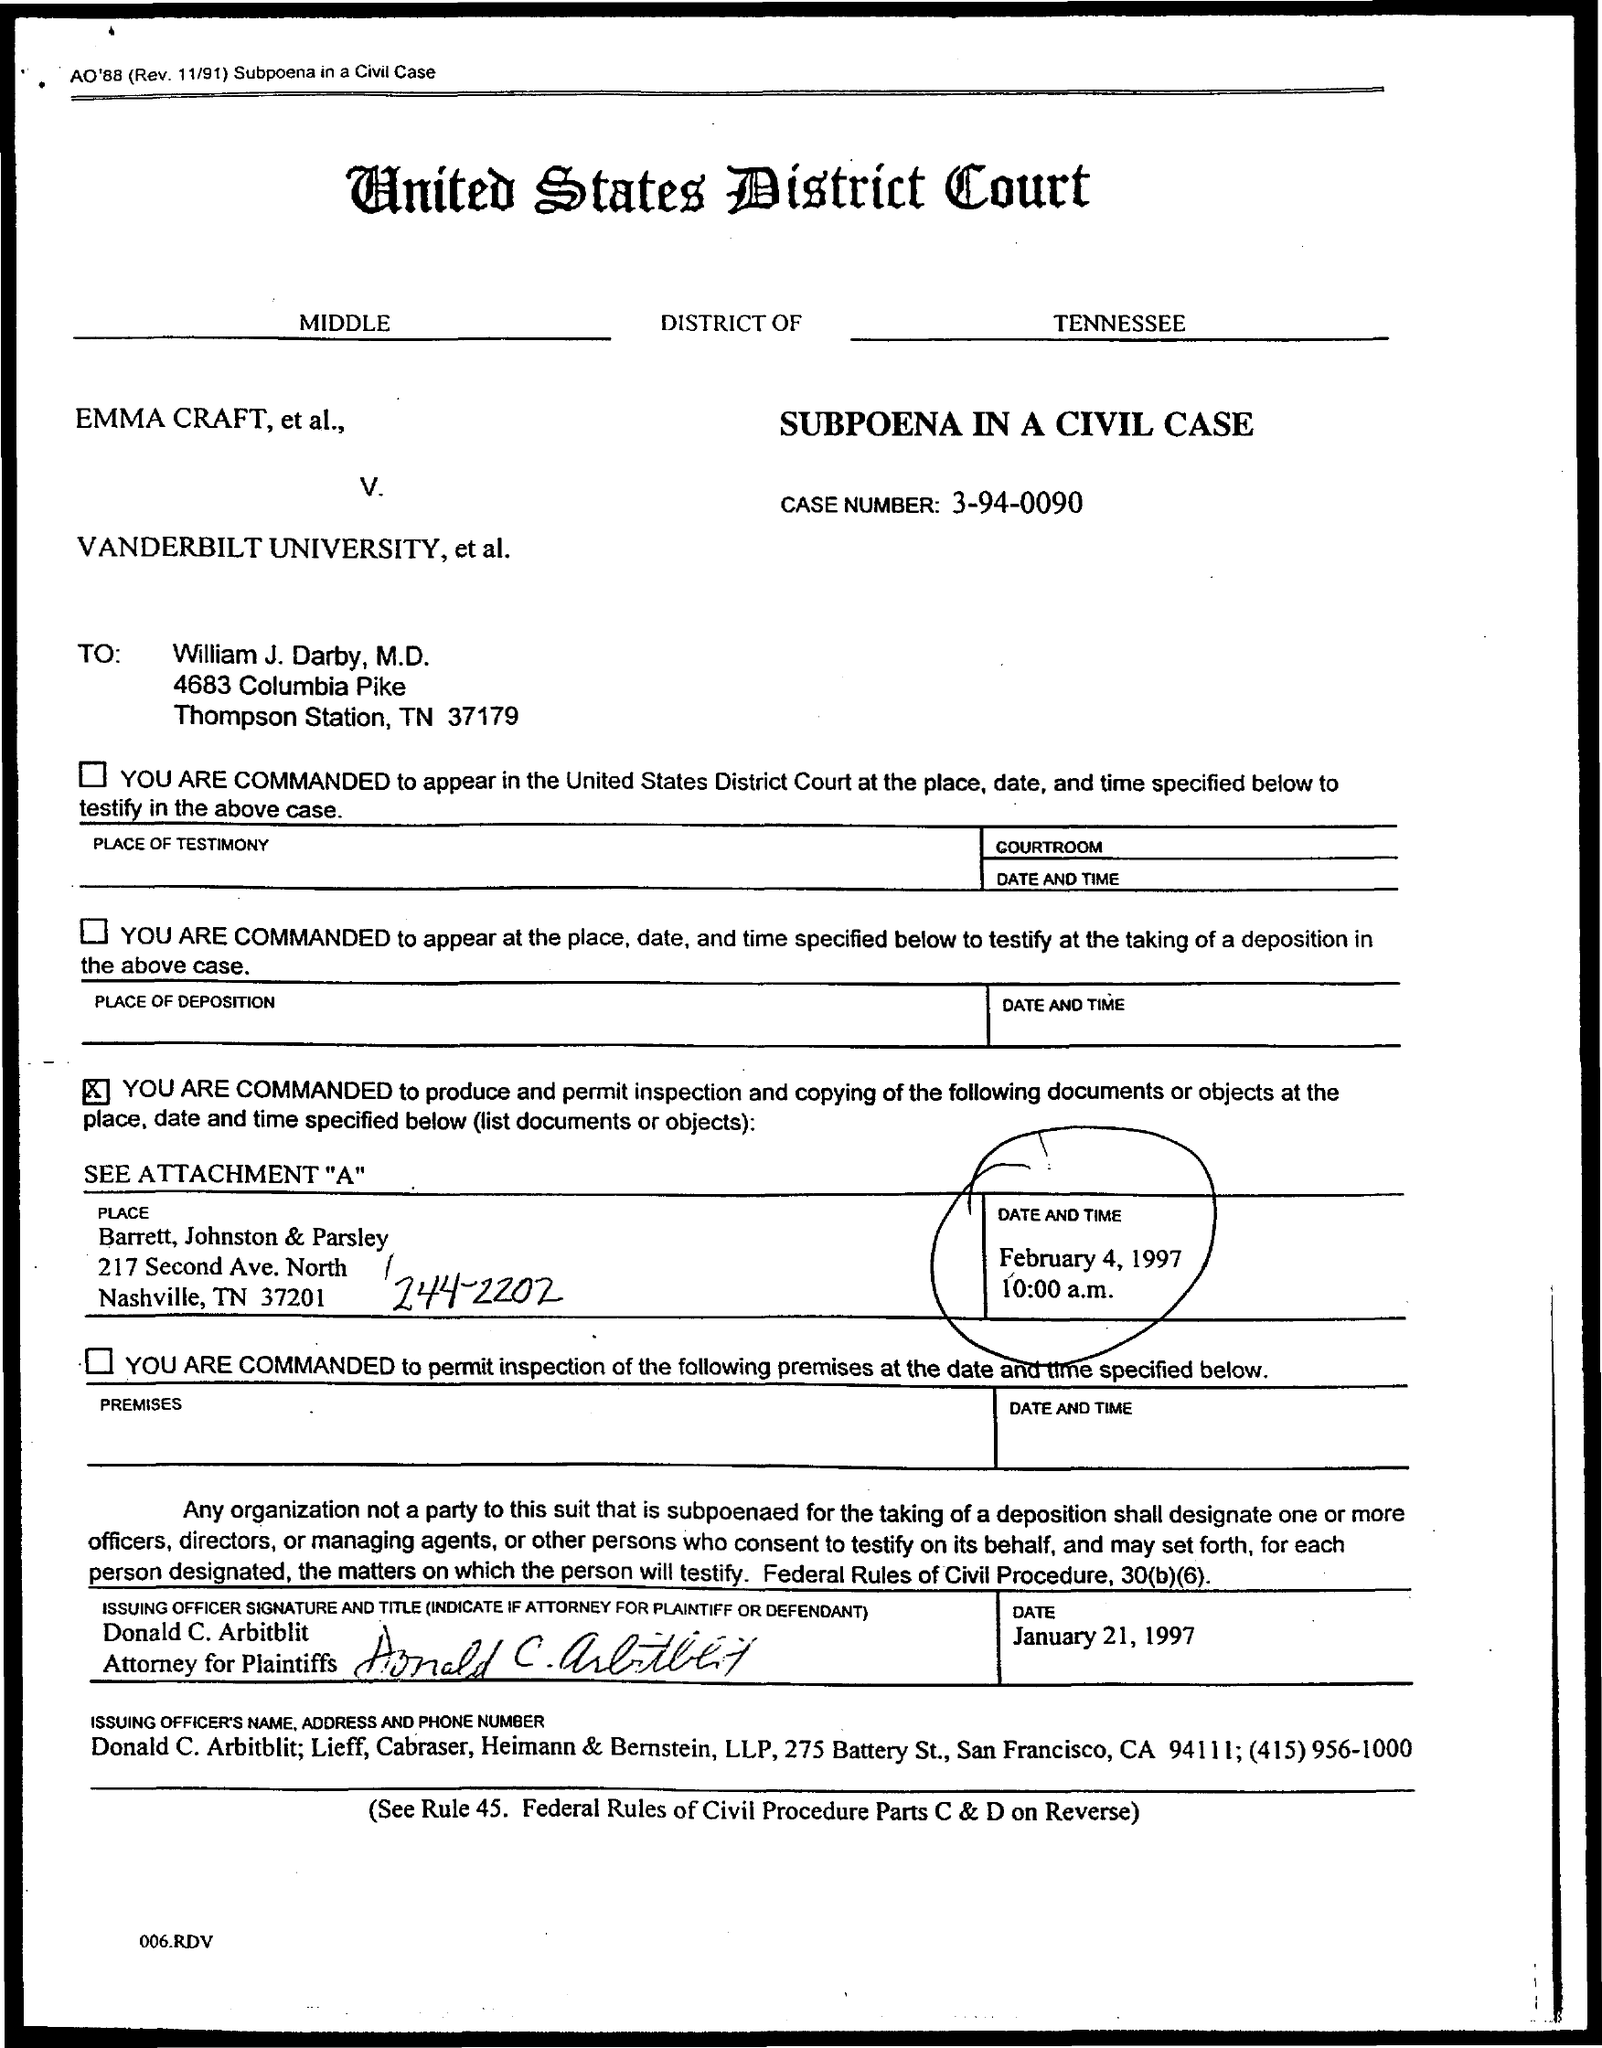What is the case number given in the document?
Keep it short and to the point. 3-94-0090. Which district court is mentioned here?
Make the answer very short. United States District Court. To whom, the document is addressed?
Your answer should be very brief. William J. Darby. 